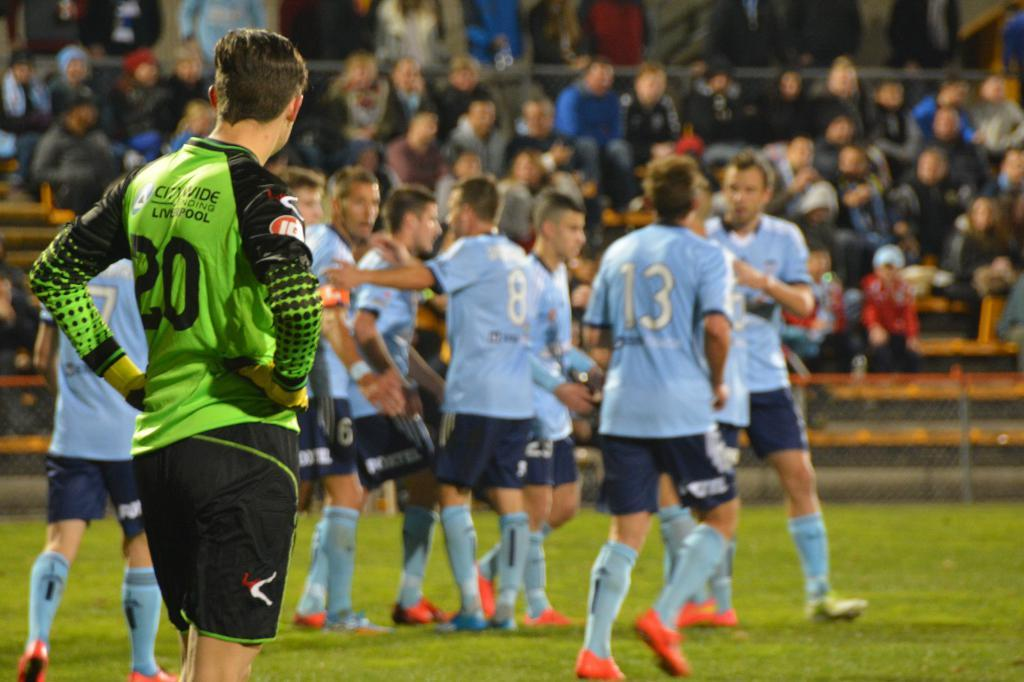Provide a one-sentence caption for the provided image. numerous soccer players wearing blue jerseys stand in a group while number 13 runs towards them. 